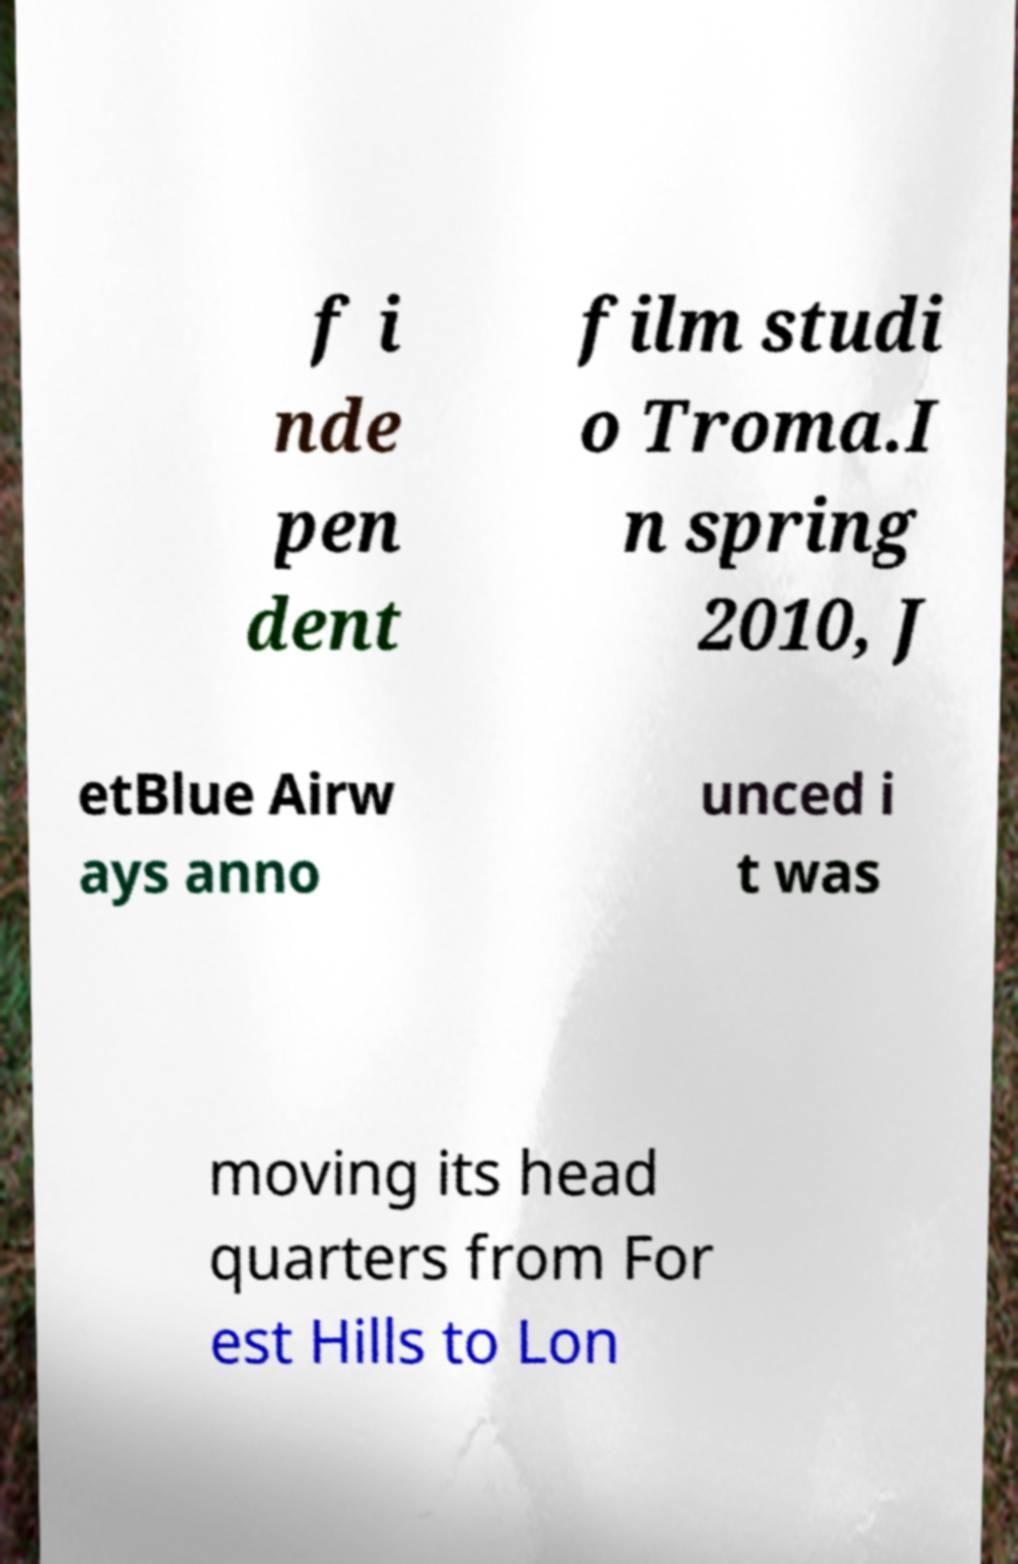Please read and relay the text visible in this image. What does it say? f i nde pen dent film studi o Troma.I n spring 2010, J etBlue Airw ays anno unced i t was moving its head quarters from For est Hills to Lon 